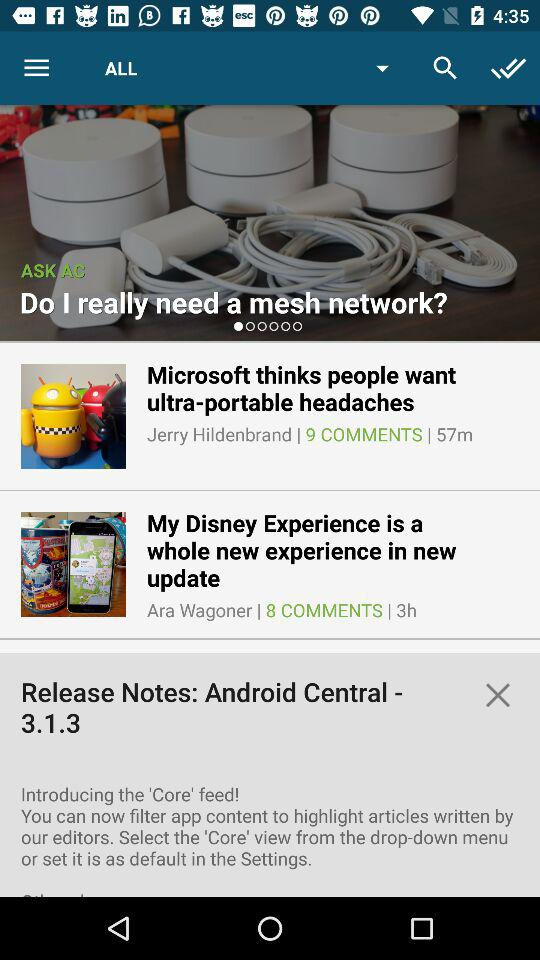Who posted "My Disney Experience"? "My Disney Experience" was posted by Ara Wagoner. 